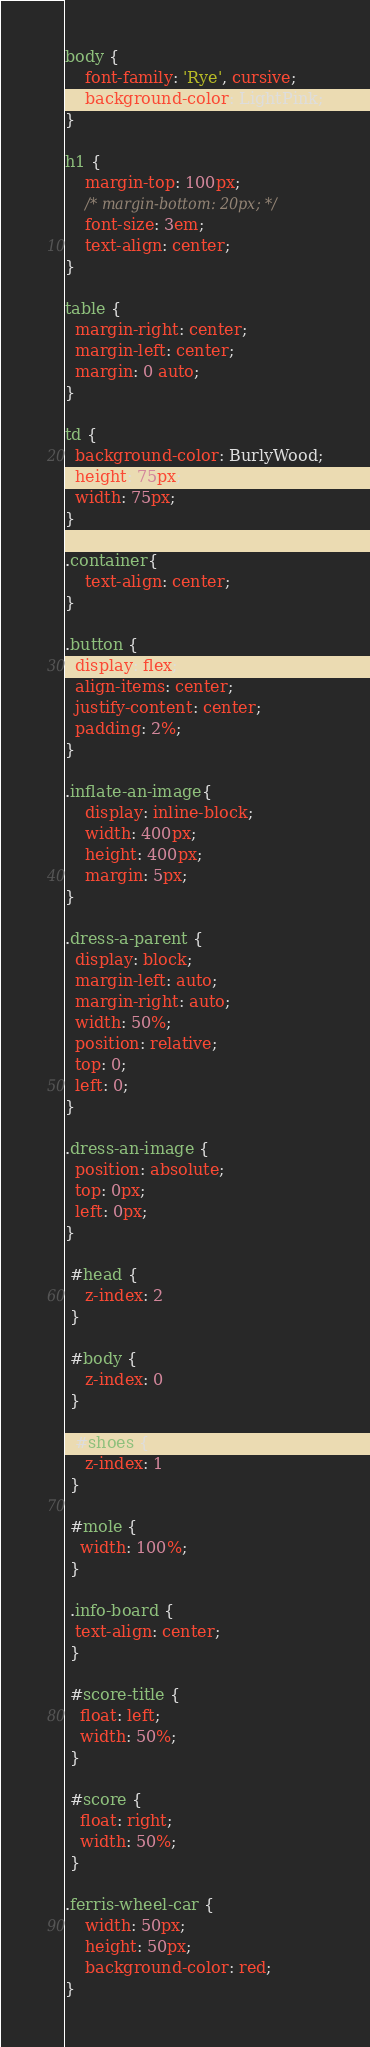<code> <loc_0><loc_0><loc_500><loc_500><_CSS_>body {
	font-family: 'Rye', cursive;
	background-color: LightPink;
}

h1 { 
	margin-top: 100px;
	/* margin-bottom: 20px; */
	font-size: 3em;
	text-align: center;
}

table {
  margin-right: center;
  margin-left: center;
  margin: 0 auto;
}

td {
  background-color: BurlyWood;
  height: 75px;
  width: 75px;
}

.container{
    text-align: center;
}

.button {
  display: flex;
  align-items: center;
  justify-content: center;
  padding: 2%;
}

.inflate-an-image{
    display: inline-block;
    width: 400px;
    height: 400px;
    margin: 5px;
}

.dress-a-parent {
  display: block;
  margin-left: auto;
  margin-right: auto;
  width: 50%;
  position: relative;
  top: 0;
  left: 0;
}

.dress-an-image {
  position: absolute;
  top: 0px;
  left: 0px;
}

 #head {
	z-index: 2
 }
 
 #body {
	z-index: 0
 }

  #shoes {
	z-index: 1
 }

 #mole {
   width: 100%;
 }

 .info-board {
  text-align: center;
 }

 #score-title {
   float: left;
   width: 50%;
 }

 #score {
   float: right;
   width: 50%;
 }

.ferris-wheel-car {
	width: 50px;
	height: 50px;
	background-color: red;
}</code> 